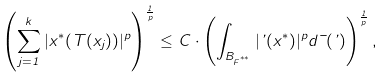<formula> <loc_0><loc_0><loc_500><loc_500>\left ( \sum _ { j = 1 } ^ { k } | x ^ { * } ( T ( x _ { j } ) ) | ^ { p } \right ) ^ { \frac { 1 } { p } } \leq C \cdot \left ( \int _ { B _ { F ^ { ^ { * * } } } } | \varphi ( x ^ { * } ) | ^ { p } d \mu ( \varphi ) \right ) ^ { \frac { 1 } { p } } ,</formula> 